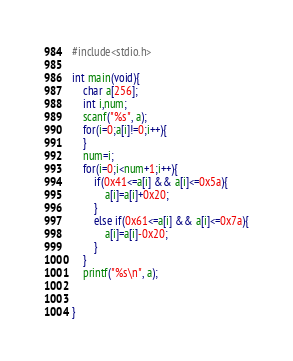Convert code to text. <code><loc_0><loc_0><loc_500><loc_500><_C_>#include<stdio.h>

int main(void){
	char a[256];
	int i,num;
	scanf("%s", a);
	for(i=0;a[i]!=0;i++){
	}
	num=i;
	for(i=0;i<num+1;i++){
		if(0x41<=a[i] && a[i]<=0x5a){
			a[i]=a[i]+0x20;
		}
		else if(0x61<=a[i] && a[i]<=0x7a){
			a[i]=a[i]-0x20;
		}
	}
	printf("%s\n", a);


}</code> 